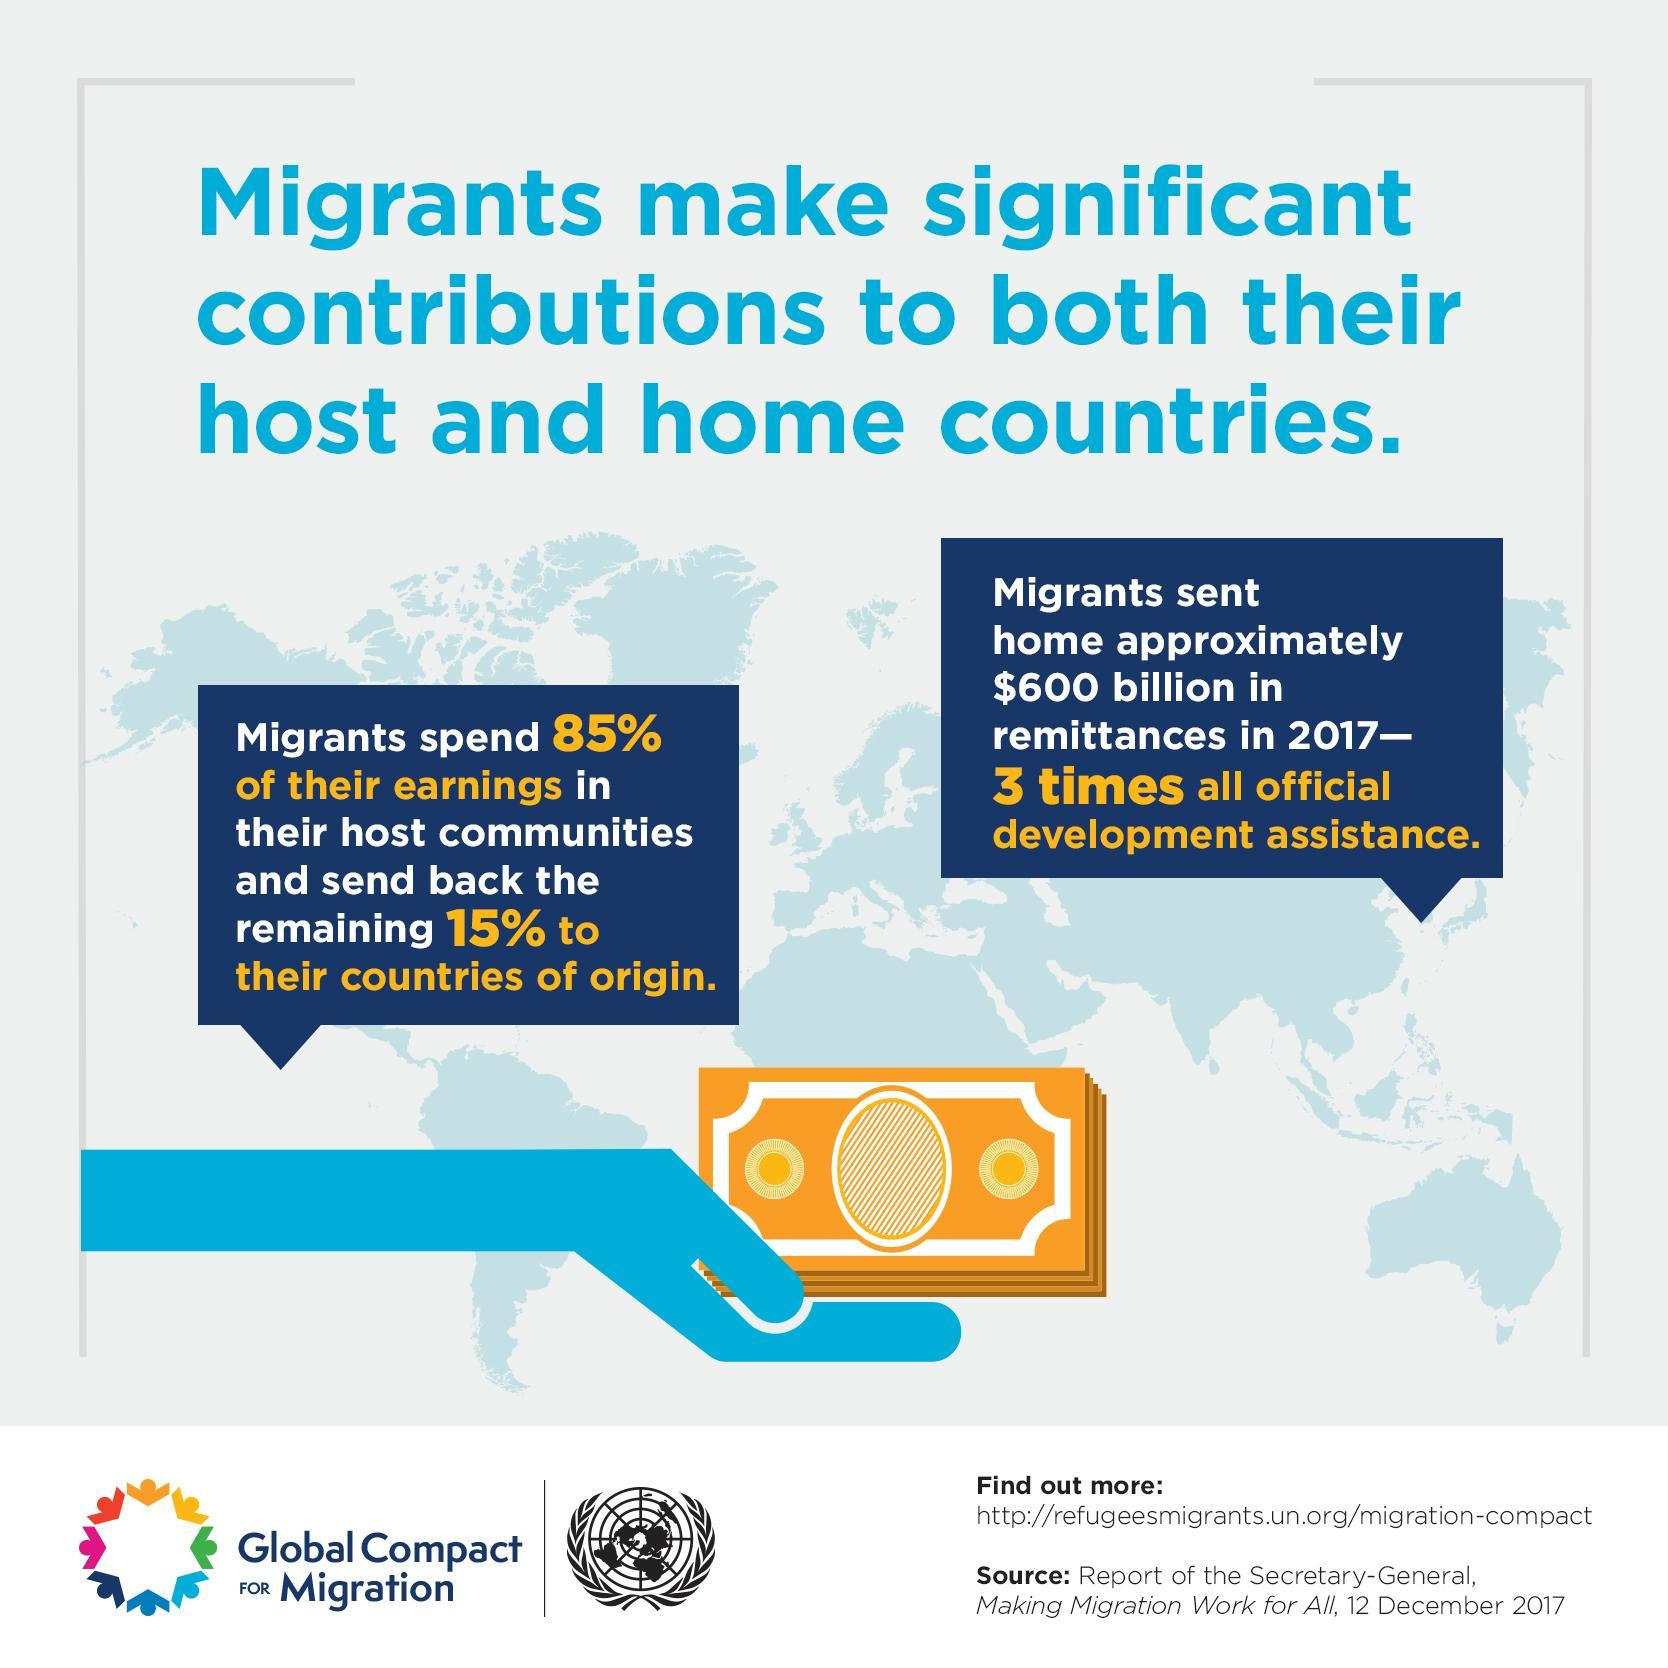what is the colour of the currency notes, blue or yellow
Answer the question with a short phrase. yellow how much do migrants spend of their earnings in their host country 85% what percent of the migrants earnings is sent to their countries of origin 15% which community is being discussed migrants 